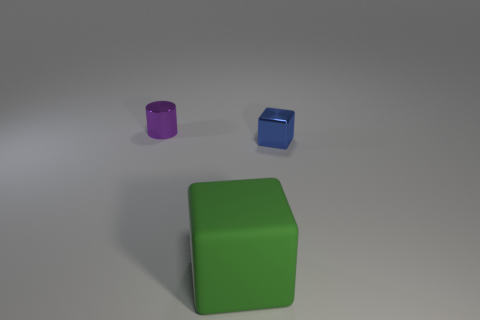What is the material of the small object in front of the metal thing behind the small block?
Ensure brevity in your answer.  Metal. Is the tiny blue thing made of the same material as the small object that is to the left of the blue thing?
Your response must be concise. Yes. What number of objects are either objects that are on the right side of the large green rubber block or tiny gray shiny objects?
Give a very brief answer. 1. Are there any tiny cubes of the same color as the big thing?
Your answer should be compact. No. There is a tiny blue object; is it the same shape as the thing in front of the blue metal block?
Your answer should be very brief. Yes. What number of objects are both in front of the tiny metallic cube and behind the big green rubber block?
Offer a very short reply. 0. There is a large green thing that is the same shape as the blue object; what is its material?
Offer a terse response. Rubber. How big is the metallic object left of the shiny thing that is to the right of the big matte cube?
Keep it short and to the point. Small. Are there any cyan balls?
Make the answer very short. No. What is the thing that is behind the big green block and in front of the shiny cylinder made of?
Make the answer very short. Metal. 